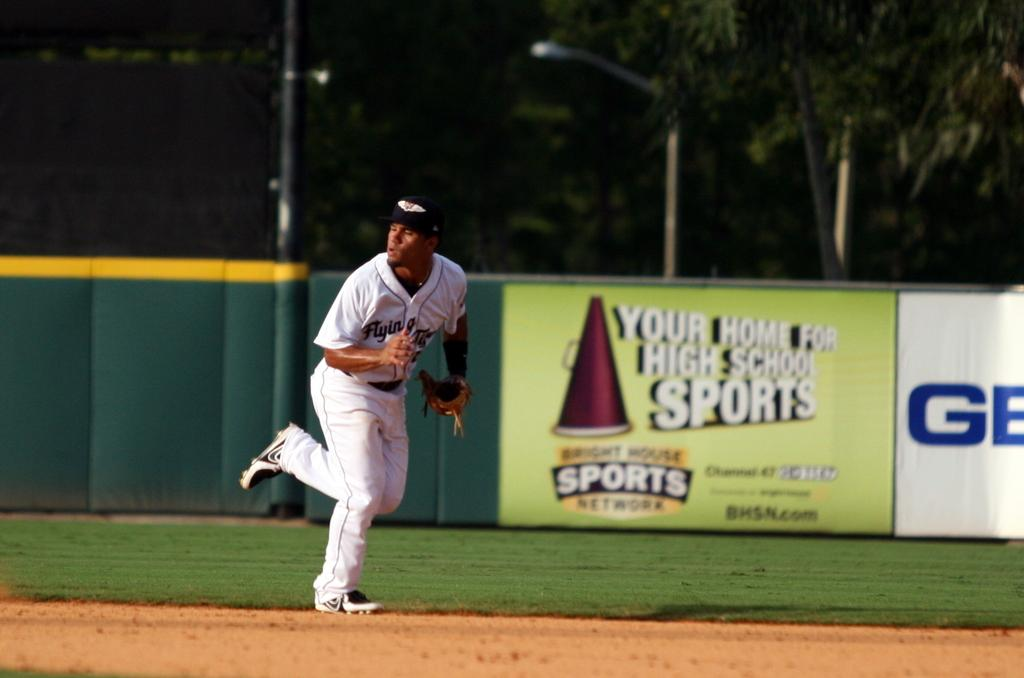<image>
Summarize the visual content of the image. A baseball player in a stadium that claims it's Your Home for High School Sports. 